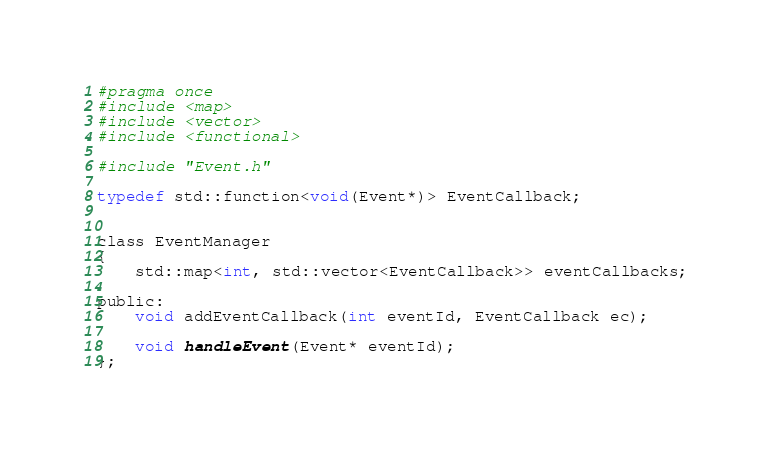<code> <loc_0><loc_0><loc_500><loc_500><_C_>#pragma once
#include <map>
#include <vector>
#include <functional>

#include "Event.h"

typedef std::function<void(Event*)> EventCallback;


class EventManager
{
	std::map<int, std::vector<EventCallback>> eventCallbacks;

public:
	void addEventCallback(int eventId, EventCallback ec);

	void handleEvent(Event* eventId);
};</code> 